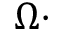<formula> <loc_0><loc_0><loc_500><loc_500>\Omega \cdot</formula> 